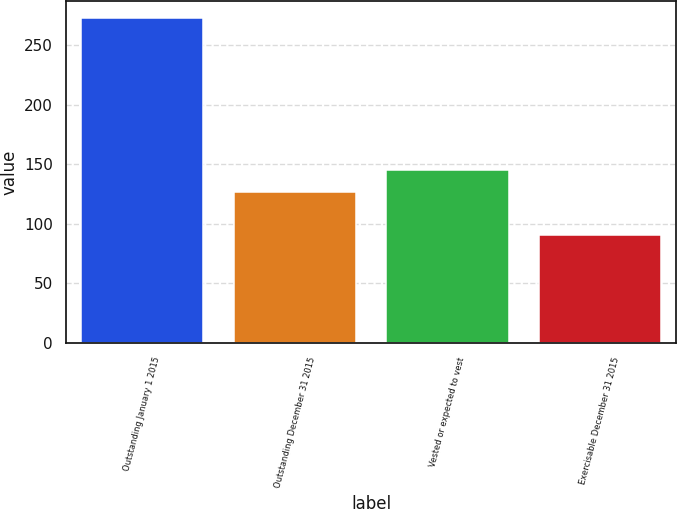Convert chart to OTSL. <chart><loc_0><loc_0><loc_500><loc_500><bar_chart><fcel>Outstanding January 1 2015<fcel>Outstanding December 31 2015<fcel>Vested or expected to vest<fcel>Exercisable December 31 2015<nl><fcel>273<fcel>127<fcel>145.2<fcel>91<nl></chart> 